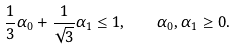<formula> <loc_0><loc_0><loc_500><loc_500>\frac { 1 } { 3 } \alpha _ { 0 } + \frac { 1 } { \sqrt { 3 } } \alpha _ { 1 } \leq 1 , \quad \alpha _ { 0 } , \alpha _ { 1 } \geq 0 .</formula> 